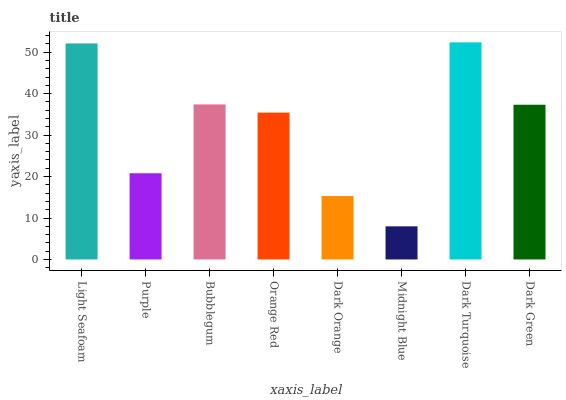Is Midnight Blue the minimum?
Answer yes or no. Yes. Is Dark Turquoise the maximum?
Answer yes or no. Yes. Is Purple the minimum?
Answer yes or no. No. Is Purple the maximum?
Answer yes or no. No. Is Light Seafoam greater than Purple?
Answer yes or no. Yes. Is Purple less than Light Seafoam?
Answer yes or no. Yes. Is Purple greater than Light Seafoam?
Answer yes or no. No. Is Light Seafoam less than Purple?
Answer yes or no. No. Is Dark Green the high median?
Answer yes or no. Yes. Is Orange Red the low median?
Answer yes or no. Yes. Is Dark Orange the high median?
Answer yes or no. No. Is Purple the low median?
Answer yes or no. No. 